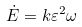<formula> <loc_0><loc_0><loc_500><loc_500>\dot { E } = k \varepsilon ^ { 2 } \omega</formula> 